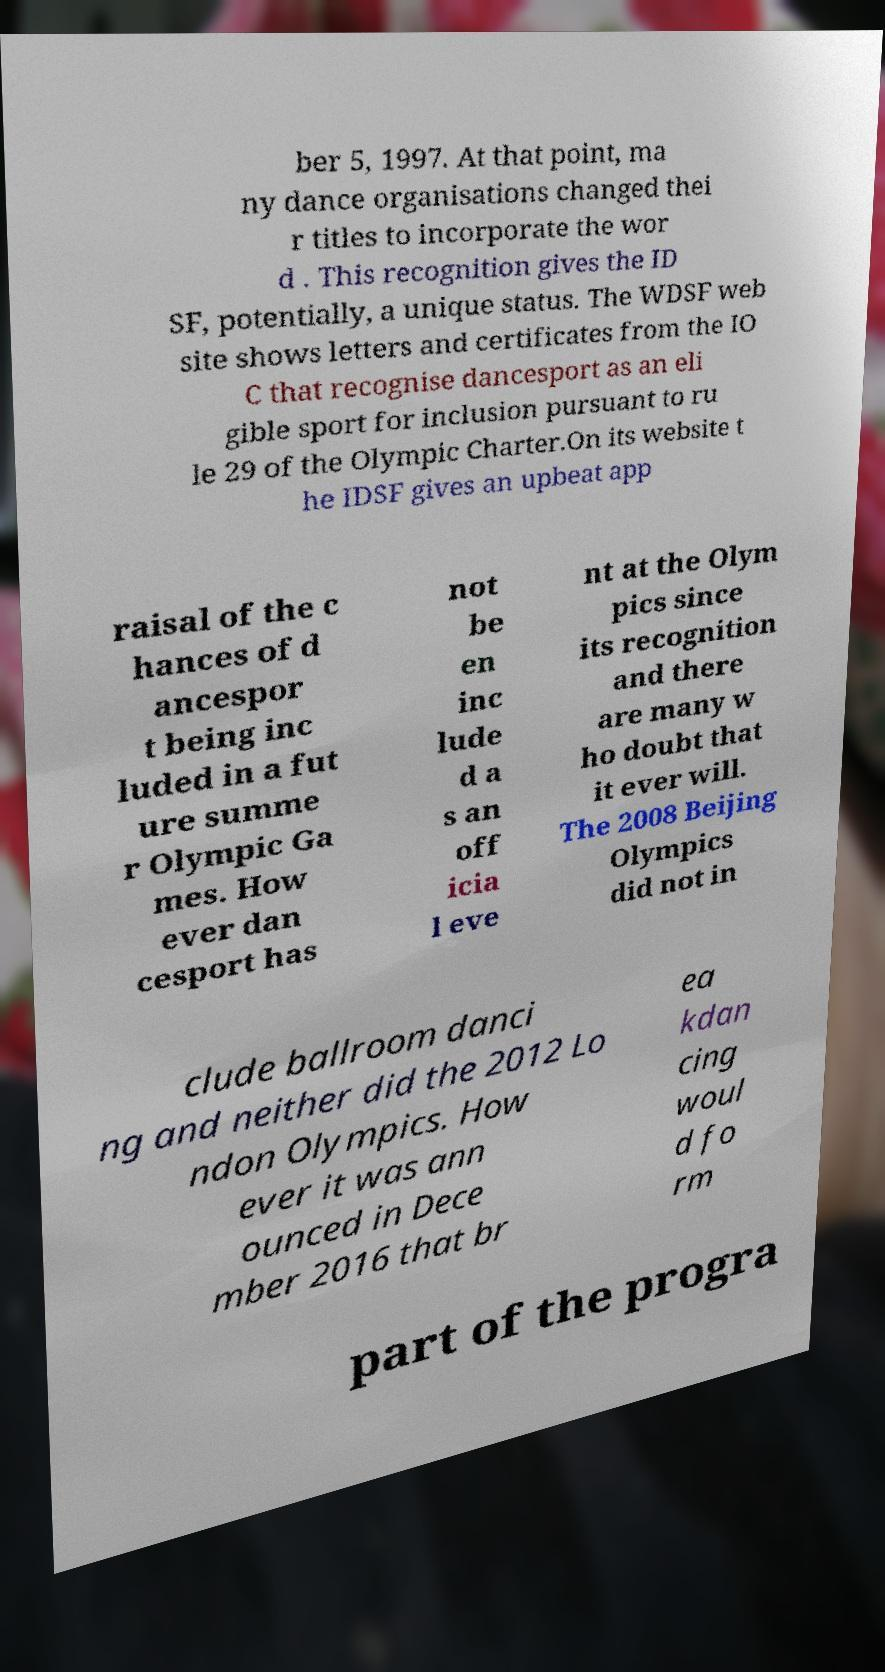I need the written content from this picture converted into text. Can you do that? ber 5, 1997. At that point, ma ny dance organisations changed thei r titles to incorporate the wor d . This recognition gives the ID SF, potentially, a unique status. The WDSF web site shows letters and certificates from the IO C that recognise dancesport as an eli gible sport for inclusion pursuant to ru le 29 of the Olympic Charter.On its website t he IDSF gives an upbeat app raisal of the c hances of d ancespor t being inc luded in a fut ure summe r Olympic Ga mes. How ever dan cesport has not be en inc lude d a s an off icia l eve nt at the Olym pics since its recognition and there are many w ho doubt that it ever will. The 2008 Beijing Olympics did not in clude ballroom danci ng and neither did the 2012 Lo ndon Olympics. How ever it was ann ounced in Dece mber 2016 that br ea kdan cing woul d fo rm part of the progra 